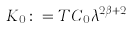<formula> <loc_0><loc_0><loc_500><loc_500>K _ { 0 } \colon = T C _ { 0 } \lambda ^ { 2 \beta + 2 }</formula> 